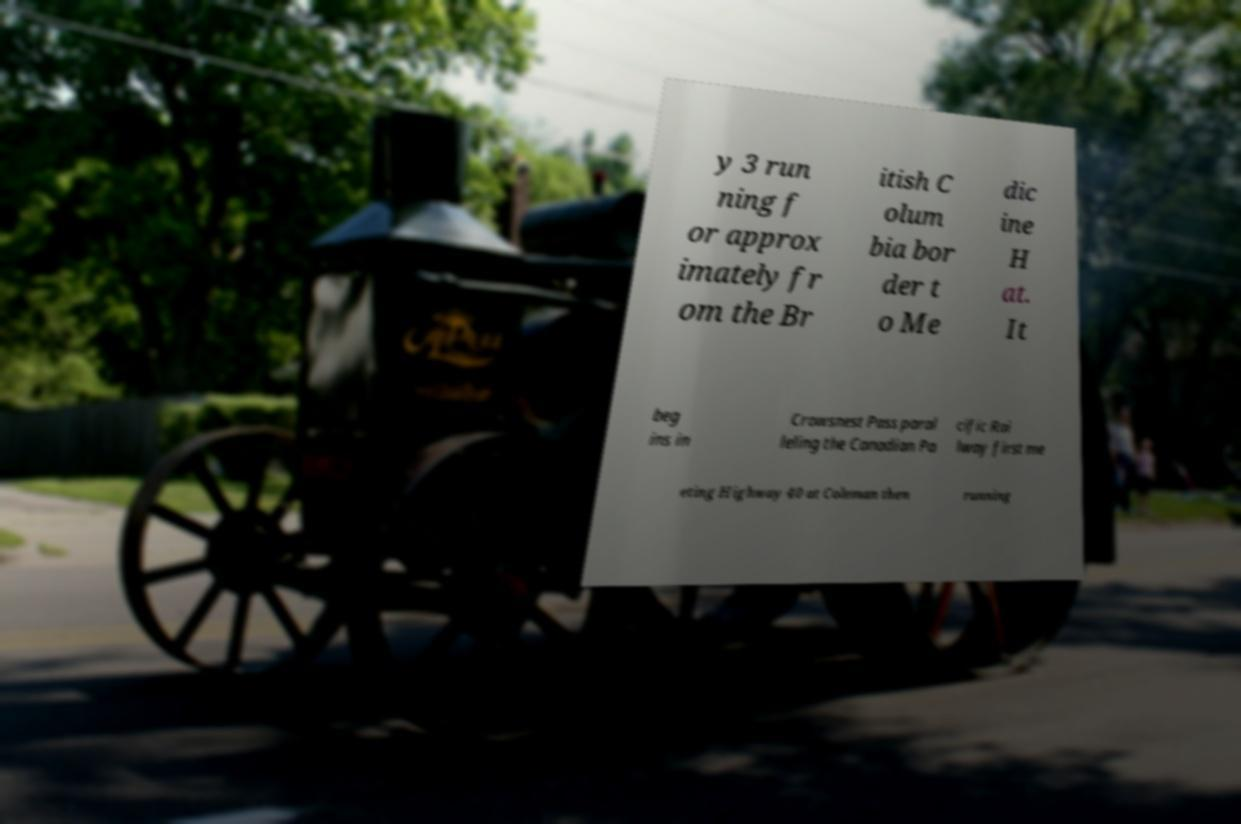Can you accurately transcribe the text from the provided image for me? y 3 run ning f or approx imately fr om the Br itish C olum bia bor der t o Me dic ine H at. It beg ins in Crowsnest Pass paral leling the Canadian Pa cific Rai lway first me eting Highway 40 at Coleman then running 